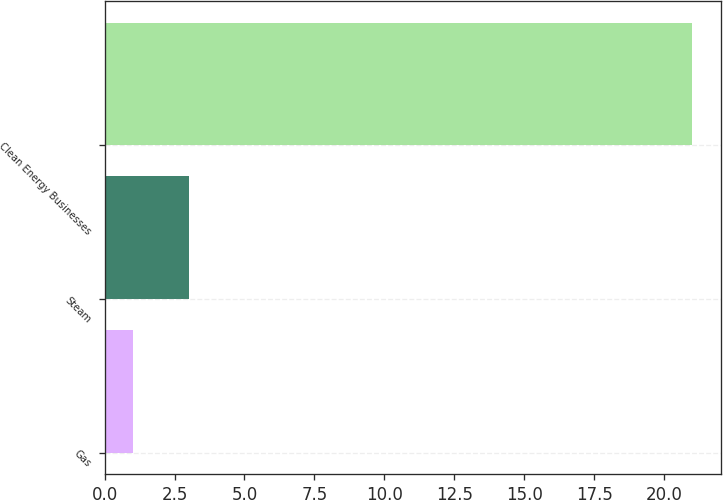<chart> <loc_0><loc_0><loc_500><loc_500><bar_chart><fcel>Gas<fcel>Steam<fcel>Clean Energy Businesses<nl><fcel>1<fcel>3<fcel>21<nl></chart> 